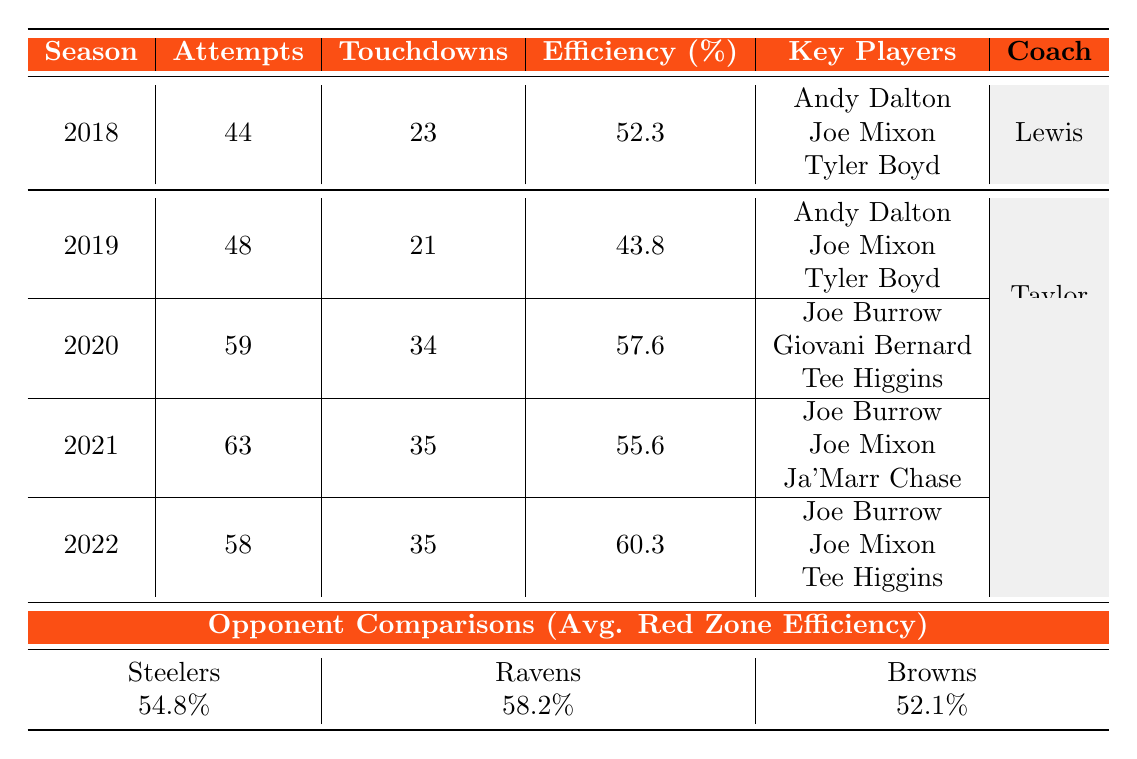What's the red zone efficiency for the 2022 season? The table shows that the red zone efficiency for the 2022 season is 60.3%.
Answer: 60.3% Which season had the highest number of red zone touchdowns? Looking at the table, the 2020 season has the highest number of touchdowns, with 34.
Answer: 2020 How many red zone attempts did the Bengals have in 2021? The table indicates that the Bengals had 63 red zone attempts in the 2021 season.
Answer: 63 What is the average red zone efficiency for Zac Taylor's coaching tenure? The average for Zac Taylor's seasons (2019-2022) is calculated by averaging the efficiencies: (43.8 + 57.6 + 55.6 + 60.3) / 4 = 54.3%.
Answer: 54.3% Did the Bengals have more red zone attempts in 2019 than in 2020? The table shows 48 attempts in 2019 and 59 in 2020, meaning they had more attempts in 2020.
Answer: No Which coach had the higher average red zone efficiency? Marvin Lewis had an efficiency of 52.3%, while Zac Taylor's average is 54.3%, so Zac Taylor had a higher average.
Answer: Zac Taylor How many more touchdowns did the Bengals score in the red zone in 2020 compared to 2019? The difference between the touchdowns in 2020 (34) and 2019 (21) is 34 - 21 = 13 touchdowns.
Answer: 13 What percentage of red zone attempts resulted in touchdowns in 2018? To find the percentage, divide the touchdowns (23) by the attempts (44) and multiply by 100: (23/44) * 100 = 52.3%.
Answer: 52.3% Which season had the lowest red zone efficiency? The table shows that 2019 had the lowest red zone efficiency at 43.8%.
Answer: 2019 How do the Bengals' red zone efficiency stats compare to the Ravens? The Ravens have an average efficiency of 58.2%. The Bengals had efficiencies of 52.3%, 43.8%, 57.6%, 55.6%, and 60.3%, so the Bengals' average efficiency (54.3%) is lower than the Ravens'.
Answer: Lower 